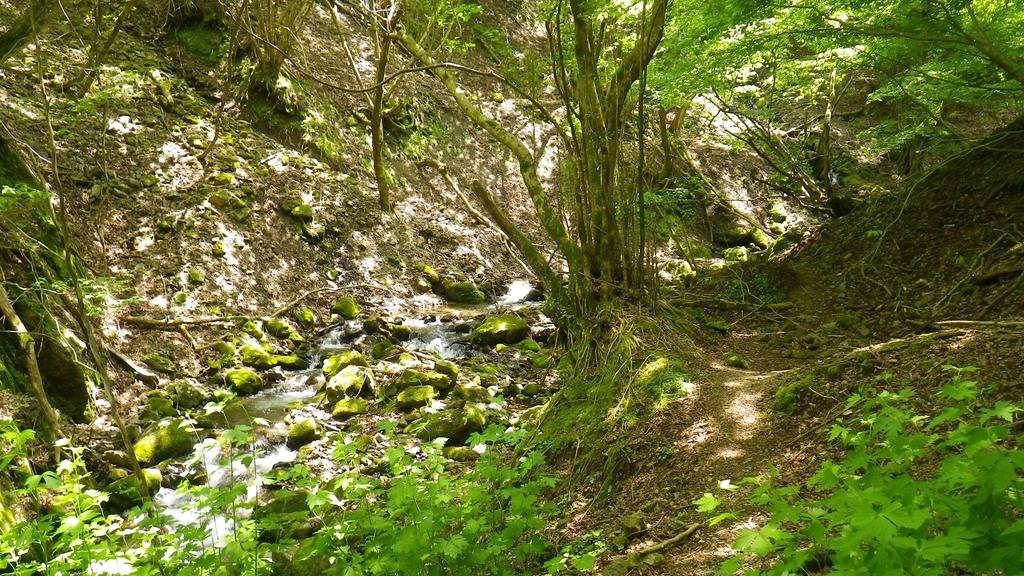What is the primary element visible in the image? There is water in the image. What other objects or features can be seen in the image? There are rocks, plants, and trees in the image. What type of jewel is the actor wearing in the image? There is no actor or jewel present in the image; it features water, rocks, plants, and trees. 